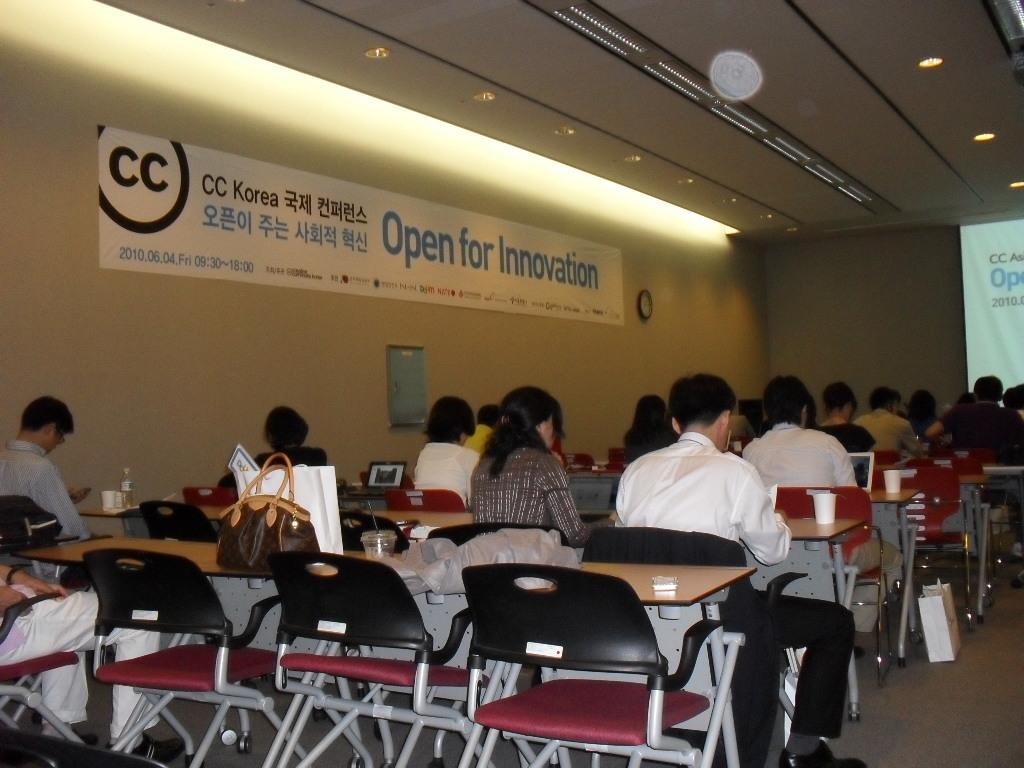What are the people in the image doing? The people in the image are sitting in chairs at tables. What is in front of the people? There is a screen in front of the people. What can be seen on the screen? The image does not provide enough information to determine what is on the screen. What is the title of the flex in the image? The title of the flex in the image is "Open for Innovation." How many hats can be seen on the people in the image? There are no hats visible in the image. What type of camera is being used by the people in the image? There is no camera visible in the image. 